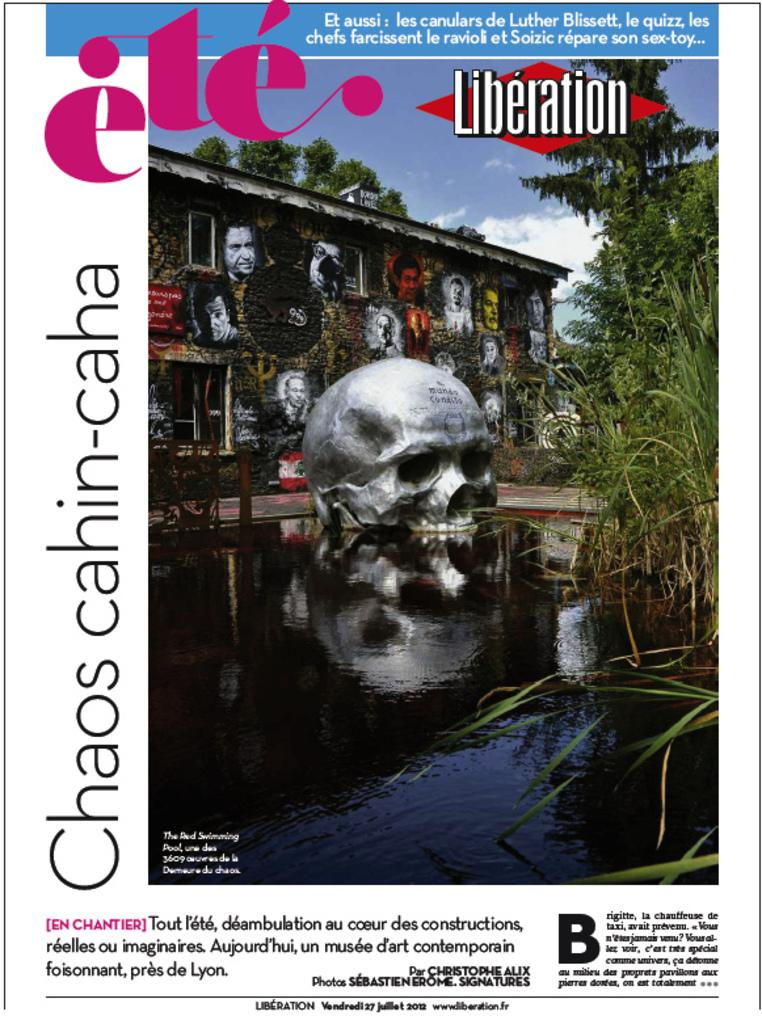What is visible in the image? Water is visible in the image. What type of vegetation can be seen on the right side of the image? There are trees on the right side of the image. What is visible in the sky at the top of the image? There are clouds in the sky at the top of the image. What taste can be experienced from the water in the image? The taste of the water cannot be determined from the image, as taste is not a visual characteristic. 